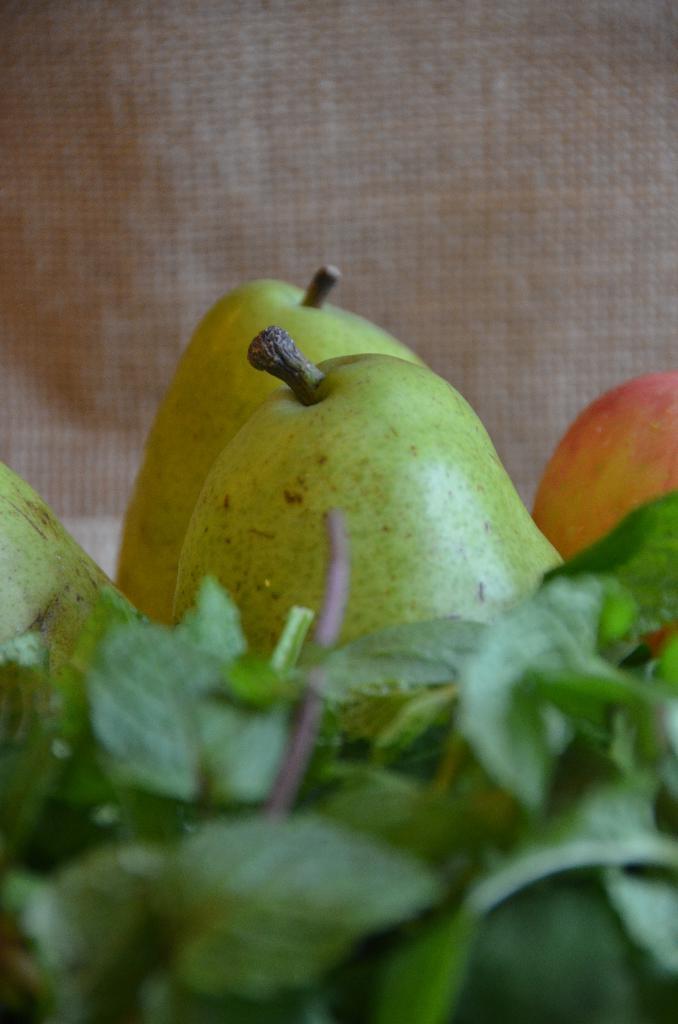Please provide a concise description of this image. This image consists of fruits along with leaves. In the background, it looks like a mat. 